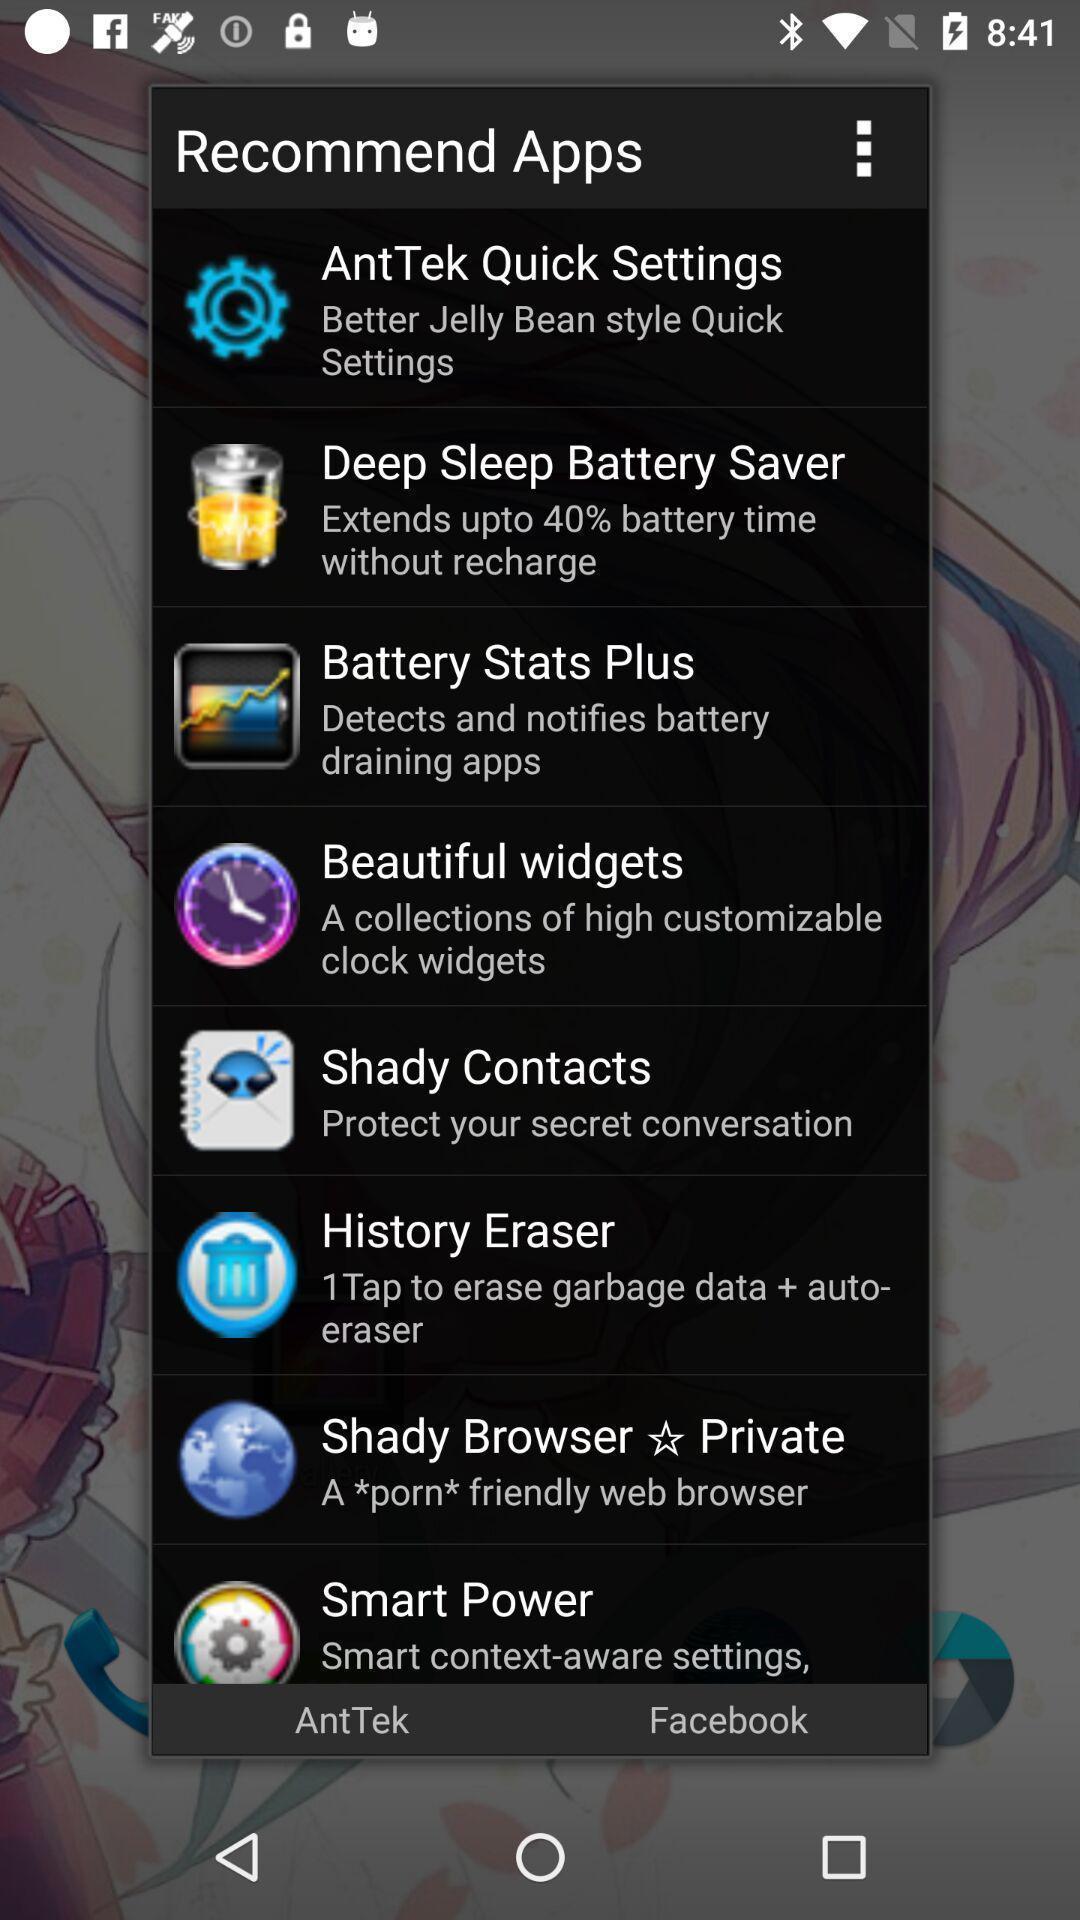Provide a detailed account of this screenshot. Pop-up with list of recommended apps. 